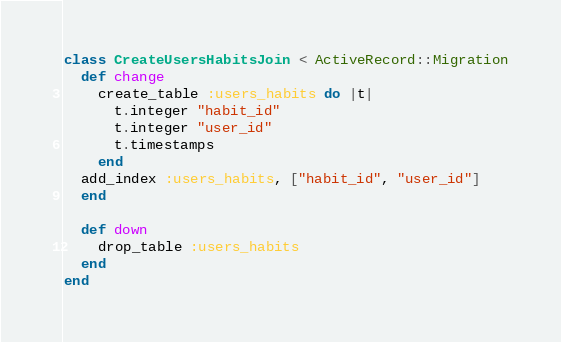Convert code to text. <code><loc_0><loc_0><loc_500><loc_500><_Ruby_>class CreateUsersHabitsJoin < ActiveRecord::Migration
  def change
    create_table :users_habits do |t|
      t.integer "habit_id"
      t.integer "user_id"
      t.timestamps
    end
  add_index :users_habits, ["habit_id", "user_id"]
  end
  
  def down
    drop_table :users_habits
  end
end</code> 